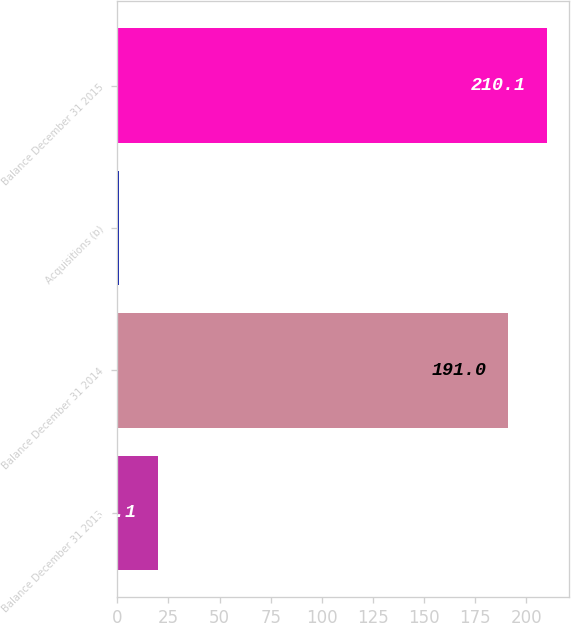Convert chart to OTSL. <chart><loc_0><loc_0><loc_500><loc_500><bar_chart><fcel>Balance December 31 2013<fcel>Balance December 31 2014<fcel>Acquisitions (b)<fcel>Balance December 31 2015<nl><fcel>20.1<fcel>191<fcel>1<fcel>210.1<nl></chart> 